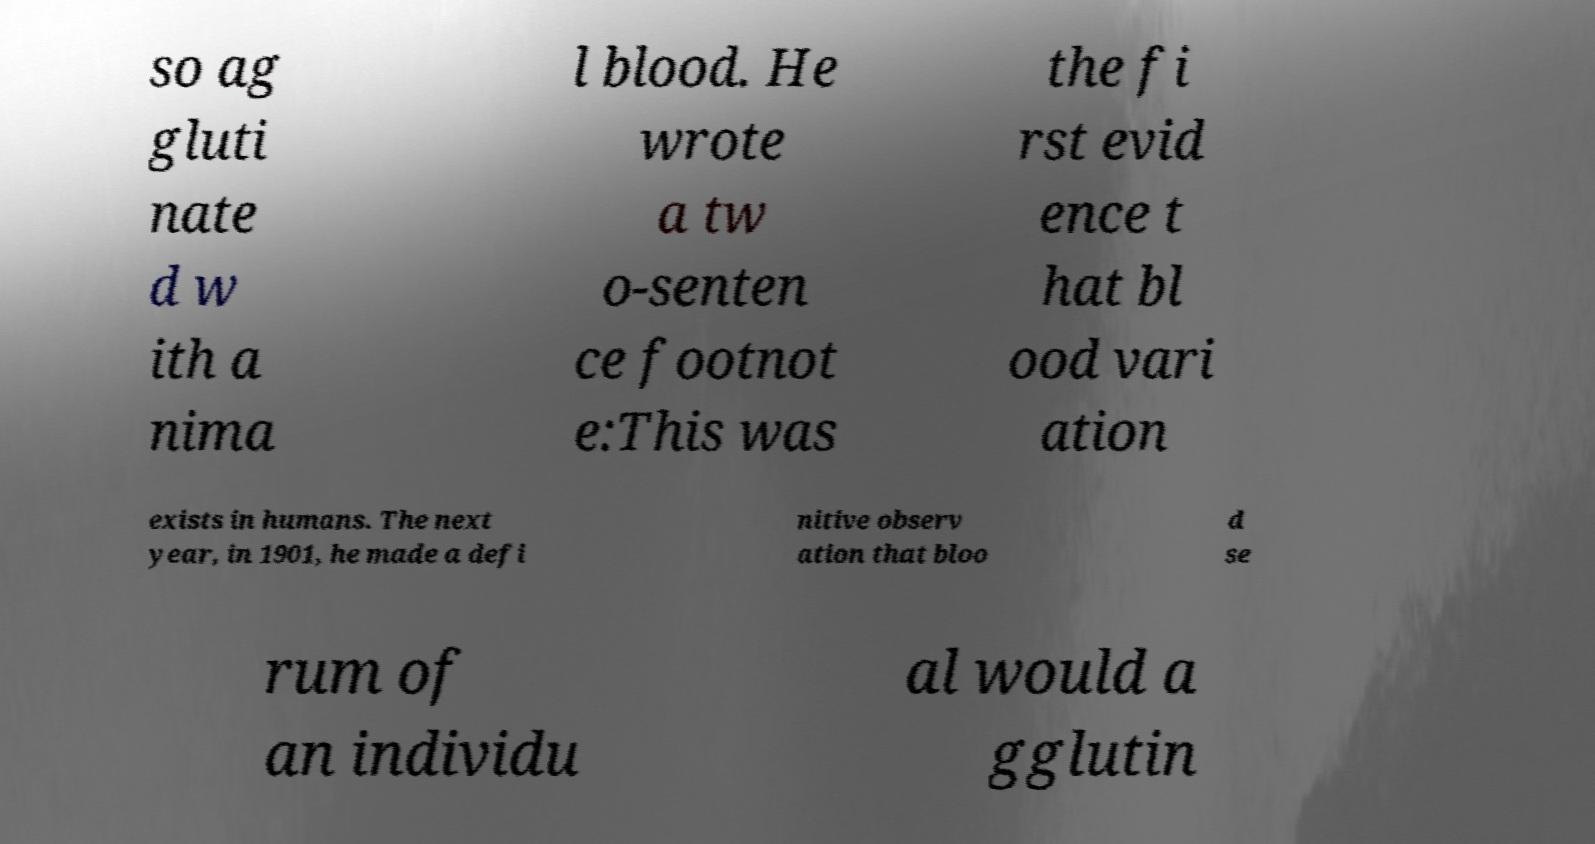Can you read and provide the text displayed in the image?This photo seems to have some interesting text. Can you extract and type it out for me? so ag gluti nate d w ith a nima l blood. He wrote a tw o-senten ce footnot e:This was the fi rst evid ence t hat bl ood vari ation exists in humans. The next year, in 1901, he made a defi nitive observ ation that bloo d se rum of an individu al would a gglutin 